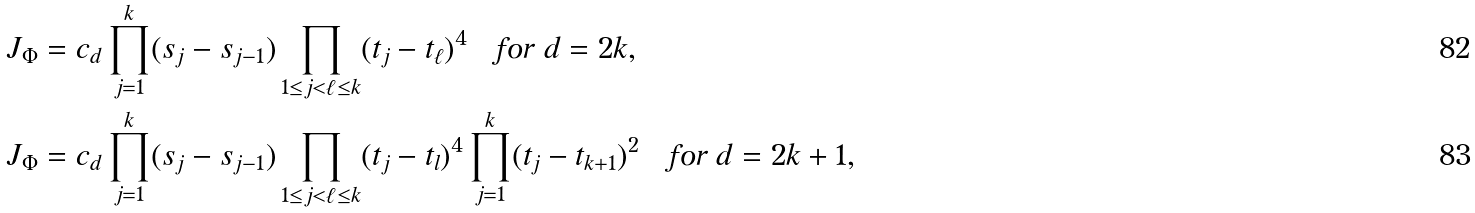<formula> <loc_0><loc_0><loc_500><loc_500>& J _ { \Phi } = c _ { d } \prod _ { j = 1 } ^ { k } ( s _ { j } - s _ { j - 1 } ) \prod _ { 1 \leq j < \ell \leq k } ( t _ { j } - t _ { \ell } ) ^ { 4 } \quad \text {for } d = 2 k , \\ & J _ { \Phi } = c _ { d } \prod _ { j = 1 } ^ { k } ( s _ { j } - s _ { j - 1 } ) \prod _ { 1 \leq j < \ell \leq k } ( t _ { j } - t _ { l } ) ^ { 4 } \prod _ { j = 1 } ^ { k } ( t _ { j } - t _ { k + 1 } ) ^ { 2 } \quad \text {for } d = 2 k + 1 ,</formula> 